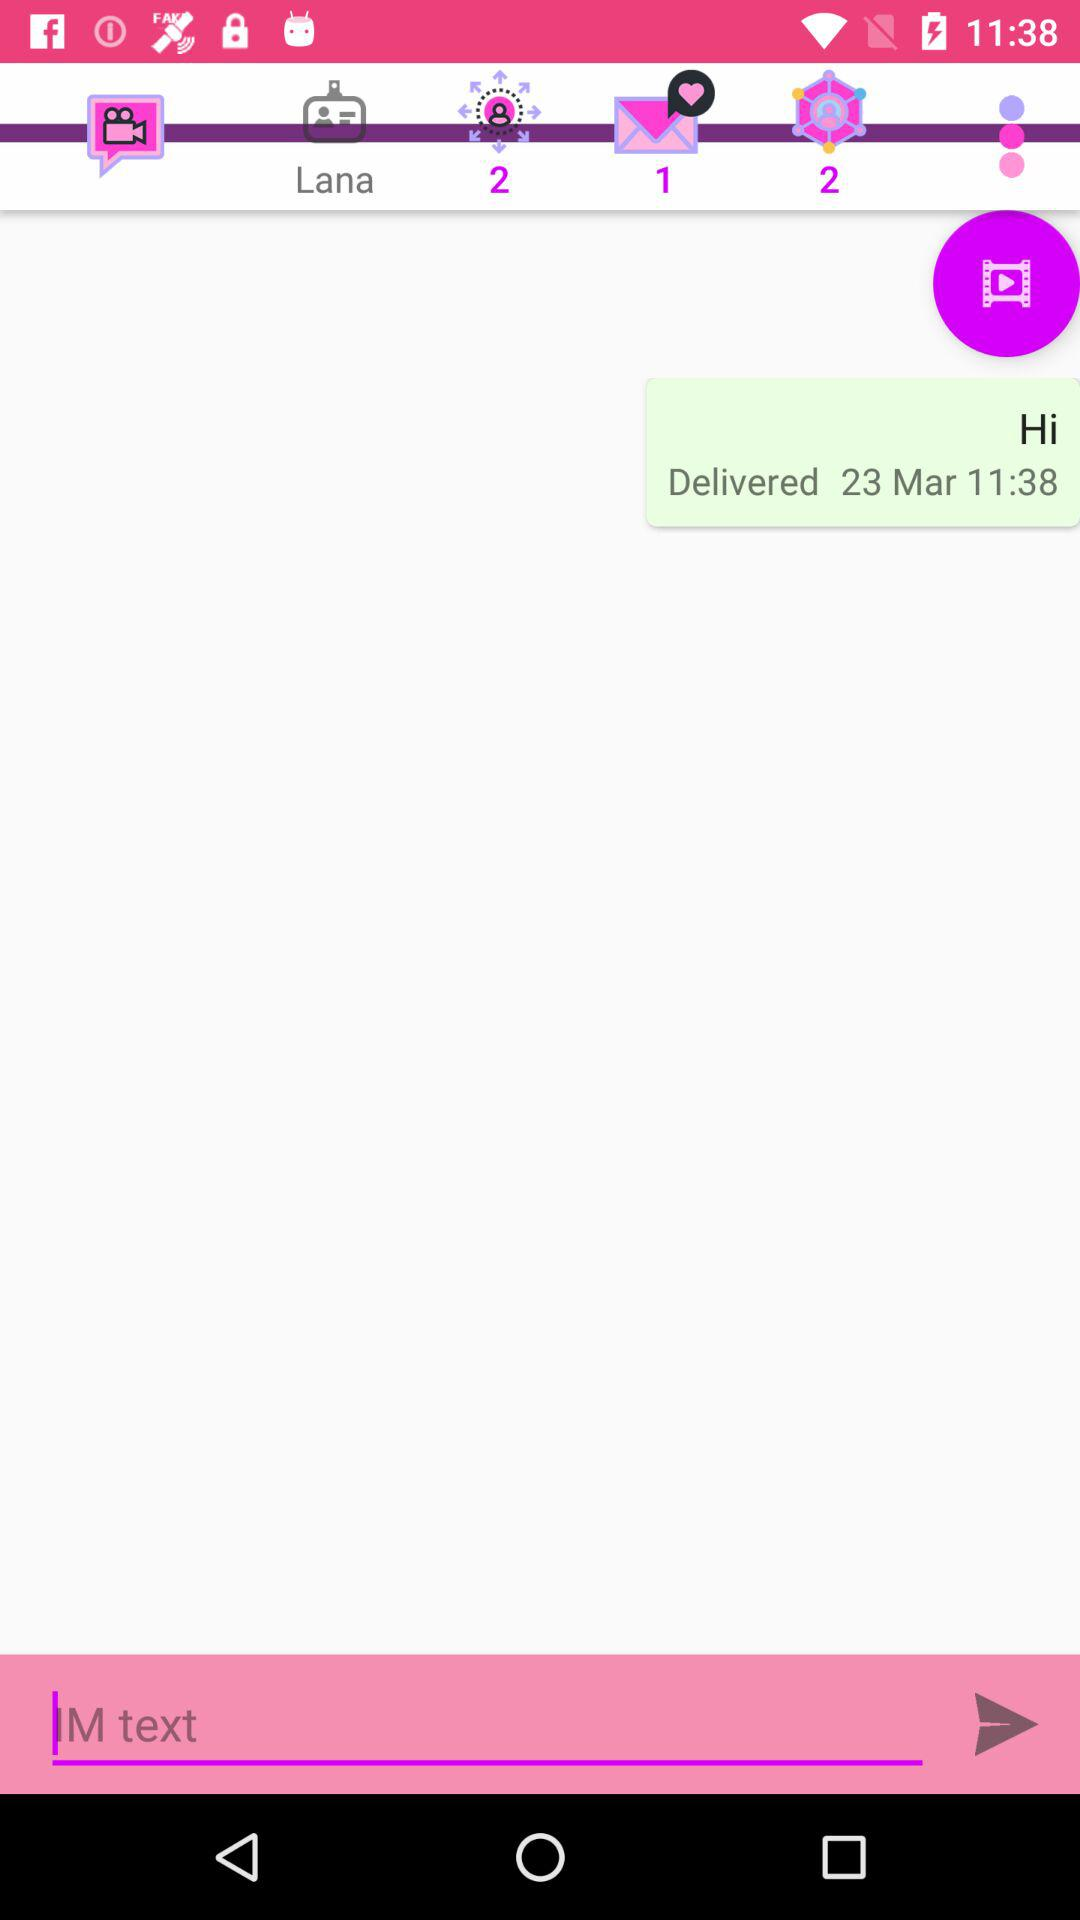On which number there is a sign of a message? A sign of a message is on number 1. 